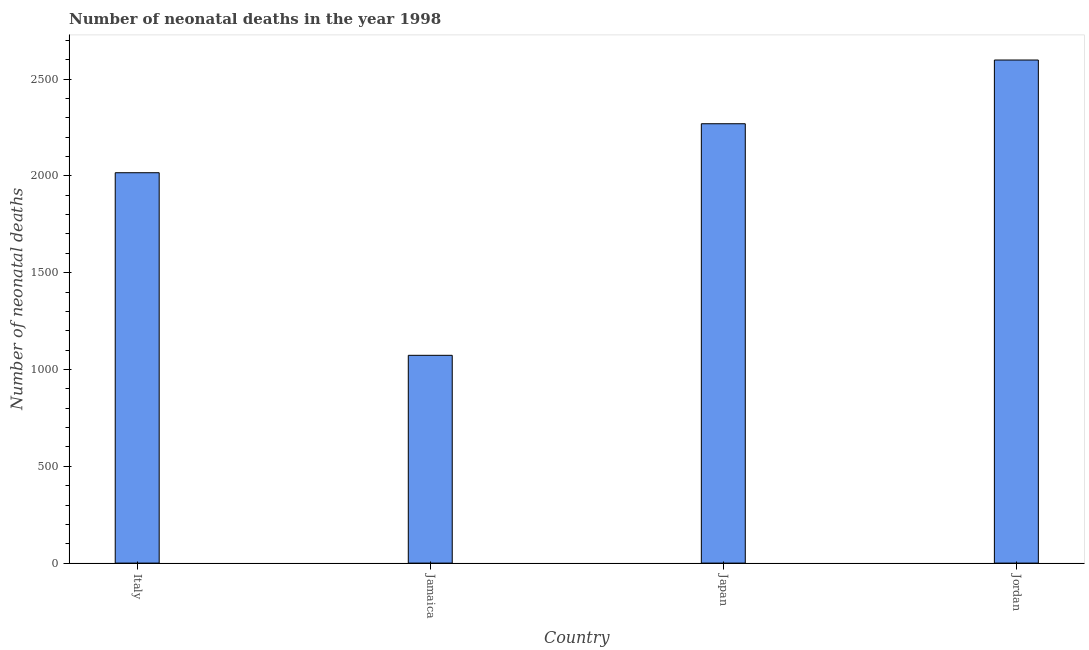What is the title of the graph?
Provide a short and direct response. Number of neonatal deaths in the year 1998. What is the label or title of the X-axis?
Make the answer very short. Country. What is the label or title of the Y-axis?
Your answer should be compact. Number of neonatal deaths. What is the number of neonatal deaths in Jordan?
Offer a very short reply. 2598. Across all countries, what is the maximum number of neonatal deaths?
Your answer should be very brief. 2598. Across all countries, what is the minimum number of neonatal deaths?
Make the answer very short. 1073. In which country was the number of neonatal deaths maximum?
Offer a terse response. Jordan. In which country was the number of neonatal deaths minimum?
Your response must be concise. Jamaica. What is the sum of the number of neonatal deaths?
Give a very brief answer. 7956. What is the difference between the number of neonatal deaths in Italy and Japan?
Offer a terse response. -253. What is the average number of neonatal deaths per country?
Offer a terse response. 1989. What is the median number of neonatal deaths?
Your answer should be very brief. 2142.5. In how many countries, is the number of neonatal deaths greater than 1200 ?
Make the answer very short. 3. What is the ratio of the number of neonatal deaths in Jamaica to that in Japan?
Make the answer very short. 0.47. Is the number of neonatal deaths in Japan less than that in Jordan?
Provide a succinct answer. Yes. Is the difference between the number of neonatal deaths in Italy and Japan greater than the difference between any two countries?
Give a very brief answer. No. What is the difference between the highest and the second highest number of neonatal deaths?
Ensure brevity in your answer.  329. Is the sum of the number of neonatal deaths in Jamaica and Jordan greater than the maximum number of neonatal deaths across all countries?
Your answer should be compact. Yes. What is the difference between the highest and the lowest number of neonatal deaths?
Give a very brief answer. 1525. In how many countries, is the number of neonatal deaths greater than the average number of neonatal deaths taken over all countries?
Offer a terse response. 3. How many bars are there?
Your answer should be very brief. 4. How many countries are there in the graph?
Provide a short and direct response. 4. What is the Number of neonatal deaths of Italy?
Keep it short and to the point. 2016. What is the Number of neonatal deaths of Jamaica?
Provide a succinct answer. 1073. What is the Number of neonatal deaths in Japan?
Give a very brief answer. 2269. What is the Number of neonatal deaths of Jordan?
Your response must be concise. 2598. What is the difference between the Number of neonatal deaths in Italy and Jamaica?
Your response must be concise. 943. What is the difference between the Number of neonatal deaths in Italy and Japan?
Keep it short and to the point. -253. What is the difference between the Number of neonatal deaths in Italy and Jordan?
Your answer should be compact. -582. What is the difference between the Number of neonatal deaths in Jamaica and Japan?
Make the answer very short. -1196. What is the difference between the Number of neonatal deaths in Jamaica and Jordan?
Your answer should be compact. -1525. What is the difference between the Number of neonatal deaths in Japan and Jordan?
Your answer should be very brief. -329. What is the ratio of the Number of neonatal deaths in Italy to that in Jamaica?
Provide a succinct answer. 1.88. What is the ratio of the Number of neonatal deaths in Italy to that in Japan?
Provide a short and direct response. 0.89. What is the ratio of the Number of neonatal deaths in Italy to that in Jordan?
Provide a succinct answer. 0.78. What is the ratio of the Number of neonatal deaths in Jamaica to that in Japan?
Your answer should be compact. 0.47. What is the ratio of the Number of neonatal deaths in Jamaica to that in Jordan?
Your response must be concise. 0.41. What is the ratio of the Number of neonatal deaths in Japan to that in Jordan?
Make the answer very short. 0.87. 